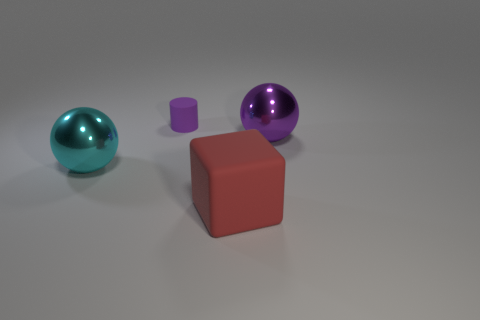Add 2 small things. How many objects exist? 6 Subtract all cyan spheres. How many spheres are left? 1 Subtract 1 spheres. How many spheres are left? 1 Subtract all cylinders. How many objects are left? 3 Subtract all blue cylinders. How many cyan balls are left? 1 Subtract all cyan blocks. Subtract all yellow cylinders. How many blocks are left? 1 Subtract all tiny purple cylinders. Subtract all large red blocks. How many objects are left? 2 Add 4 small purple matte cylinders. How many small purple matte cylinders are left? 5 Add 1 purple matte objects. How many purple matte objects exist? 2 Subtract 0 brown spheres. How many objects are left? 4 